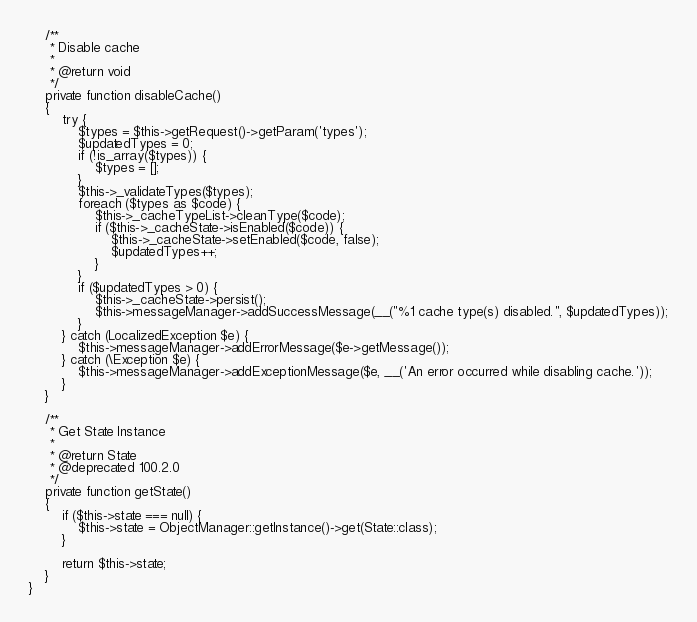<code> <loc_0><loc_0><loc_500><loc_500><_PHP_>    /**
     * Disable cache
     *
     * @return void
     */
    private function disableCache()
    {
        try {
            $types = $this->getRequest()->getParam('types');
            $updatedTypes = 0;
            if (!is_array($types)) {
                $types = [];
            }
            $this->_validateTypes($types);
            foreach ($types as $code) {
                $this->_cacheTypeList->cleanType($code);
                if ($this->_cacheState->isEnabled($code)) {
                    $this->_cacheState->setEnabled($code, false);
                    $updatedTypes++;
                }
            }
            if ($updatedTypes > 0) {
                $this->_cacheState->persist();
                $this->messageManager->addSuccessMessage(__("%1 cache type(s) disabled.", $updatedTypes));
            }
        } catch (LocalizedException $e) {
            $this->messageManager->addErrorMessage($e->getMessage());
        } catch (\Exception $e) {
            $this->messageManager->addExceptionMessage($e, __('An error occurred while disabling cache.'));
        }
    }

    /**
     * Get State Instance
     *
     * @return State
     * @deprecated 100.2.0
     */
    private function getState()
    {
        if ($this->state === null) {
            $this->state = ObjectManager::getInstance()->get(State::class);
        }

        return $this->state;
    }
}
</code> 